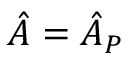Convert formula to latex. <formula><loc_0><loc_0><loc_500><loc_500>\hat { A } = \hat { A } _ { P }</formula> 